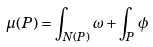<formula> <loc_0><loc_0><loc_500><loc_500>\mu ( P ) = \int _ { N ( P ) } \omega + \int _ { P } \phi</formula> 